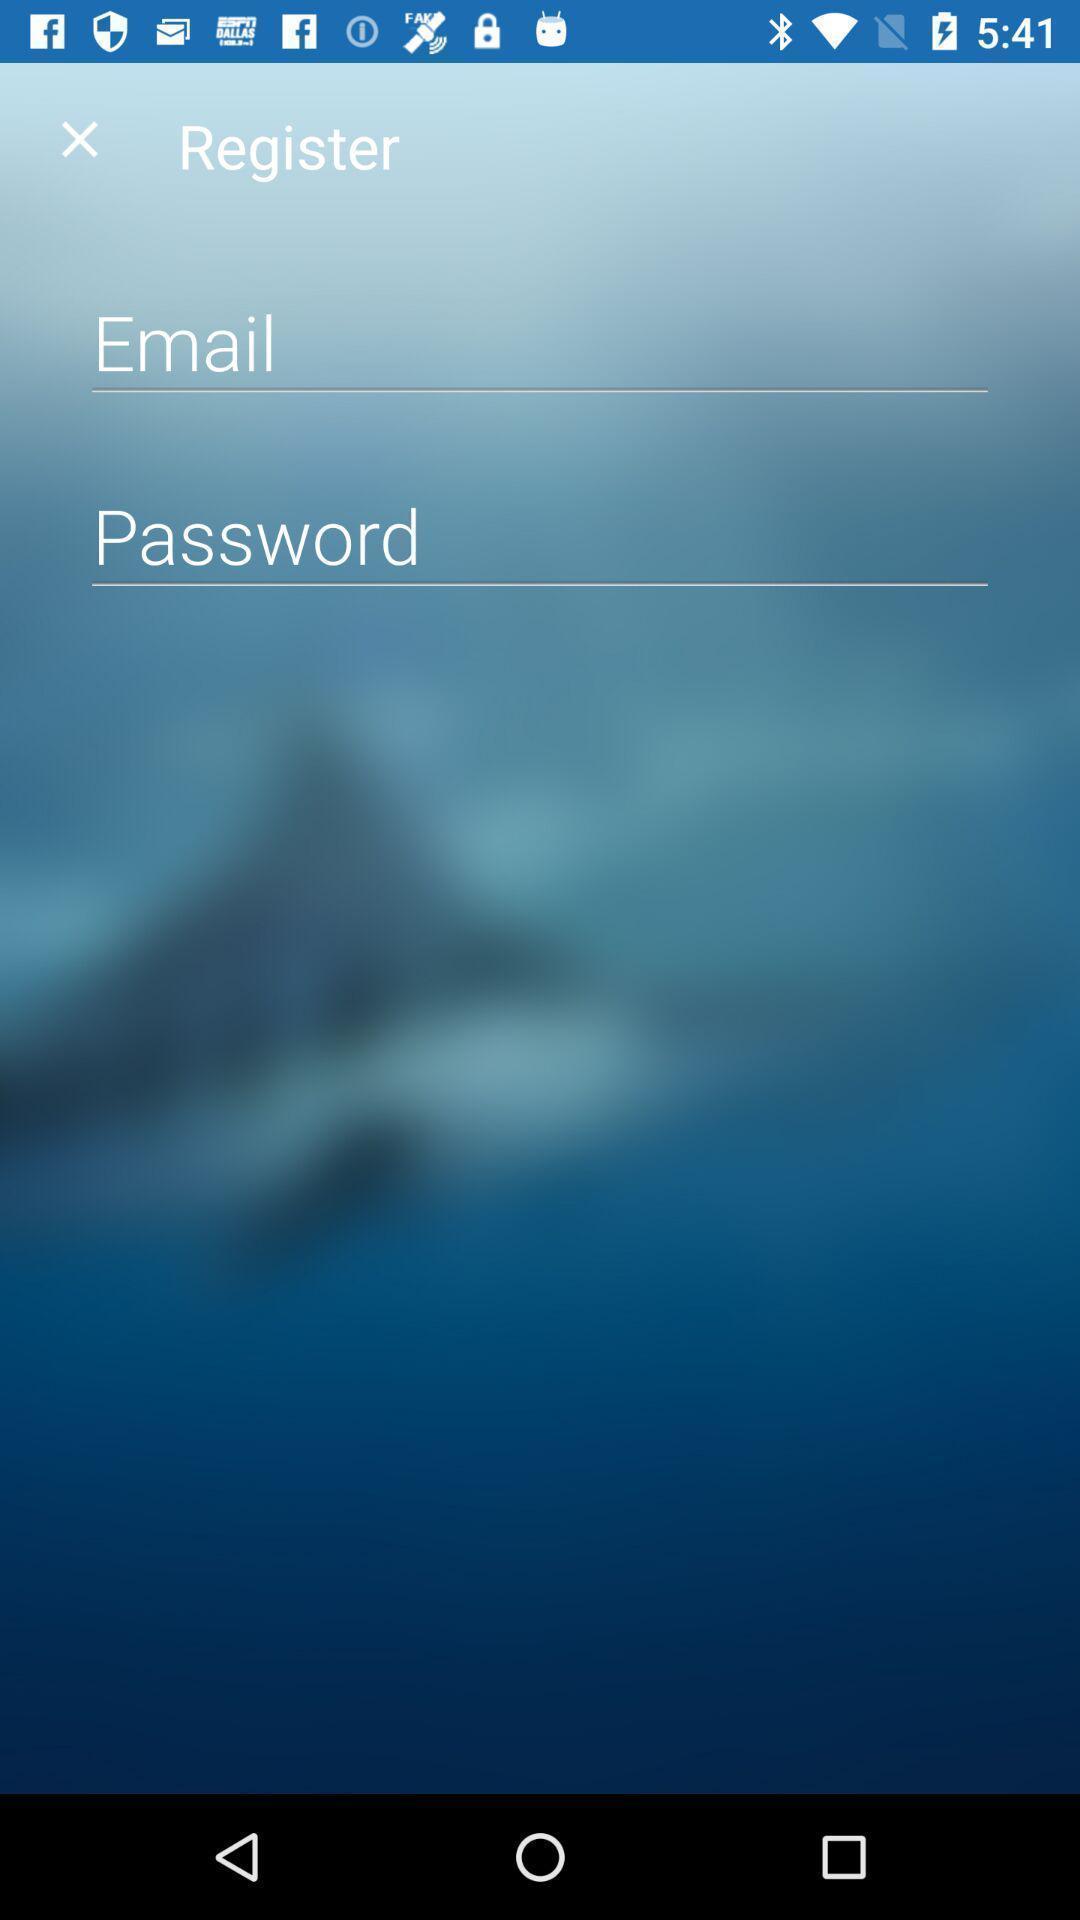Summarize the information in this screenshot. Page showing the input credentials field. 